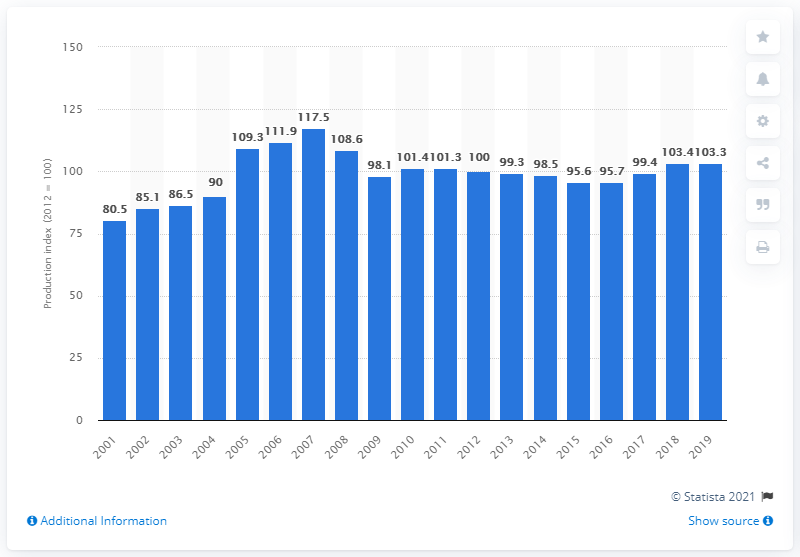Give some essential details in this illustration. In 2019, the chemical production index in the United States was 103.3, indicating a positive trend in the production of chemicals in the country. 